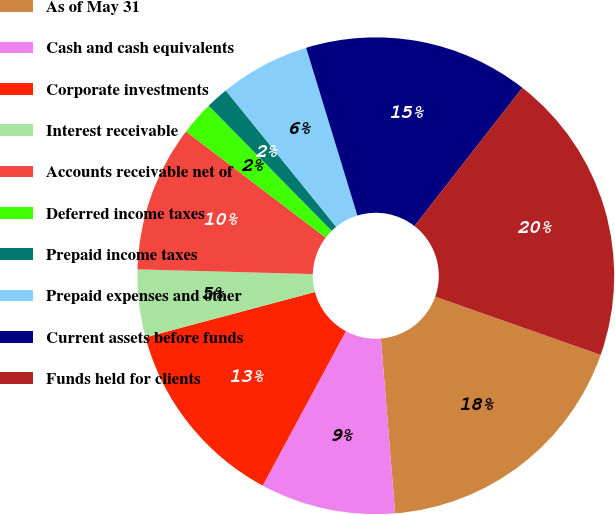<chart> <loc_0><loc_0><loc_500><loc_500><pie_chart><fcel>As of May 31<fcel>Cash and cash equivalents<fcel>Corporate investments<fcel>Interest receivable<fcel>Accounts receivable net of<fcel>Deferred income taxes<fcel>Prepaid income taxes<fcel>Prepaid expenses and other<fcel>Current assets before funds<fcel>Funds held for clients<nl><fcel>18.32%<fcel>9.16%<fcel>12.98%<fcel>4.58%<fcel>9.92%<fcel>2.29%<fcel>1.53%<fcel>6.11%<fcel>15.26%<fcel>19.84%<nl></chart> 